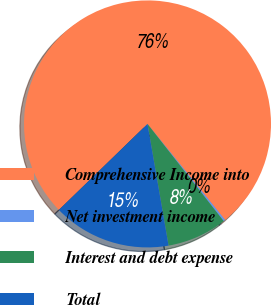Convert chart. <chart><loc_0><loc_0><loc_500><loc_500><pie_chart><fcel>Comprehensive Income into<fcel>Net investment income<fcel>Interest and debt expense<fcel>Total<nl><fcel>76.45%<fcel>0.23%<fcel>7.85%<fcel>15.47%<nl></chart> 